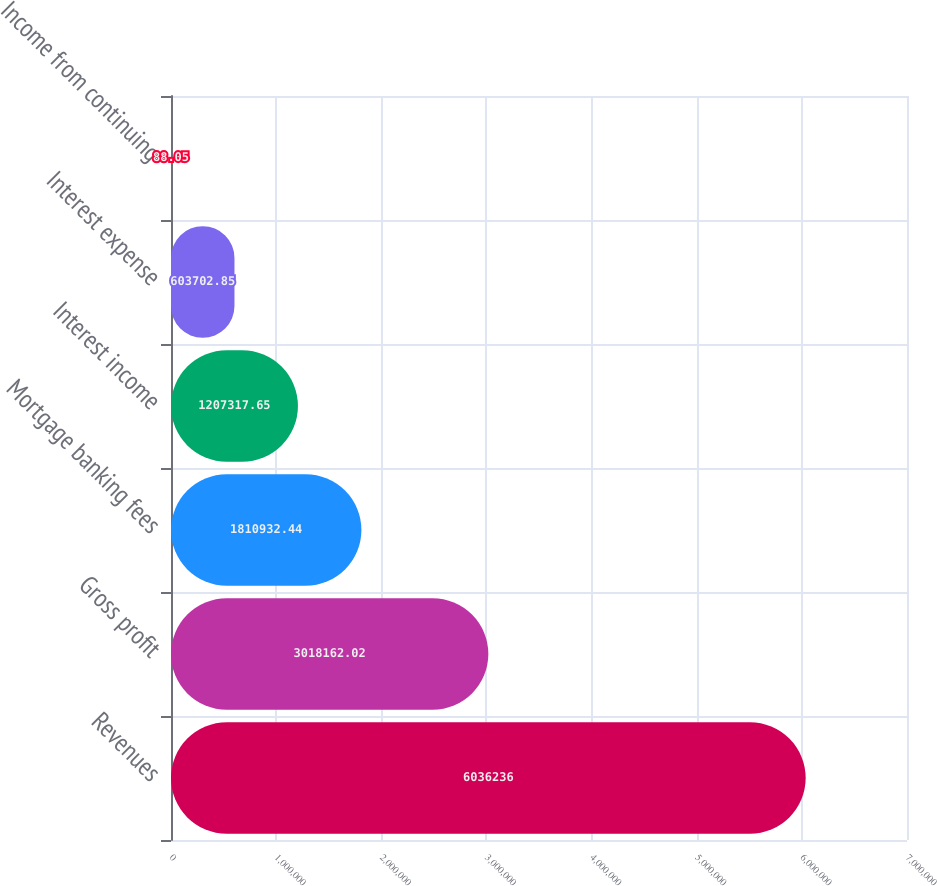<chart> <loc_0><loc_0><loc_500><loc_500><bar_chart><fcel>Revenues<fcel>Gross profit<fcel>Mortgage banking fees<fcel>Interest income<fcel>Interest expense<fcel>Income from continuing<nl><fcel>6.03624e+06<fcel>3.01816e+06<fcel>1.81093e+06<fcel>1.20732e+06<fcel>603703<fcel>88.05<nl></chart> 